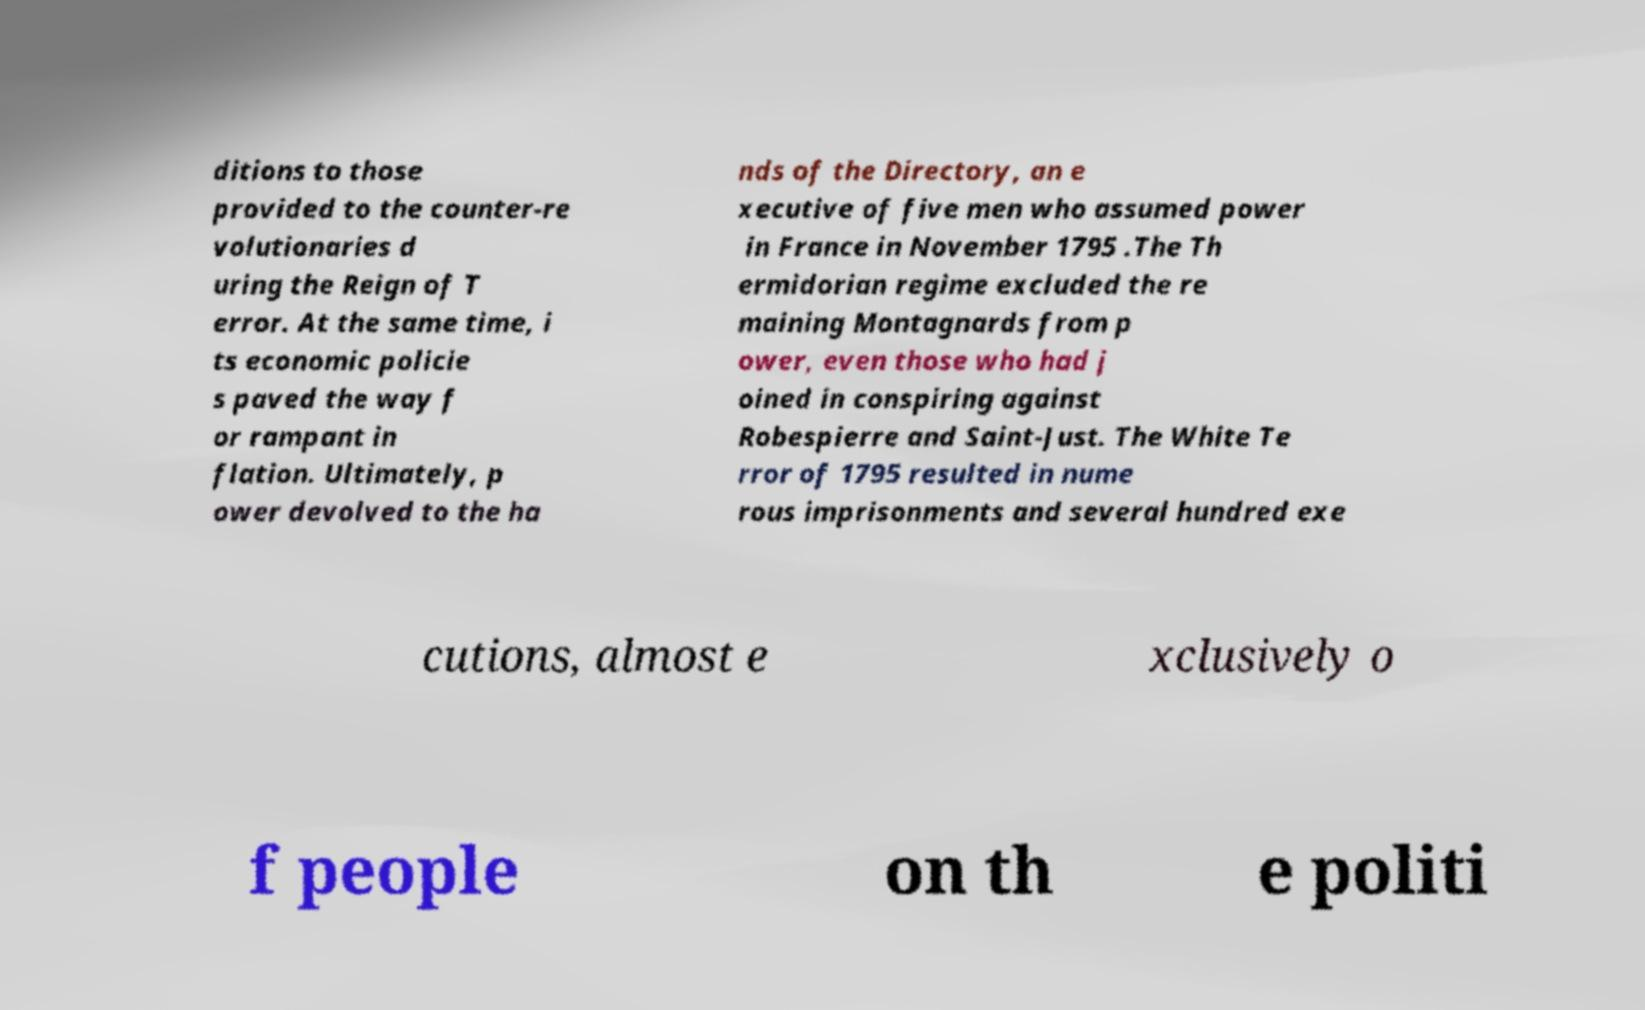For documentation purposes, I need the text within this image transcribed. Could you provide that? ditions to those provided to the counter-re volutionaries d uring the Reign of T error. At the same time, i ts economic policie s paved the way f or rampant in flation. Ultimately, p ower devolved to the ha nds of the Directory, an e xecutive of five men who assumed power in France in November 1795 .The Th ermidorian regime excluded the re maining Montagnards from p ower, even those who had j oined in conspiring against Robespierre and Saint-Just. The White Te rror of 1795 resulted in nume rous imprisonments and several hundred exe cutions, almost e xclusively o f people on th e politi 